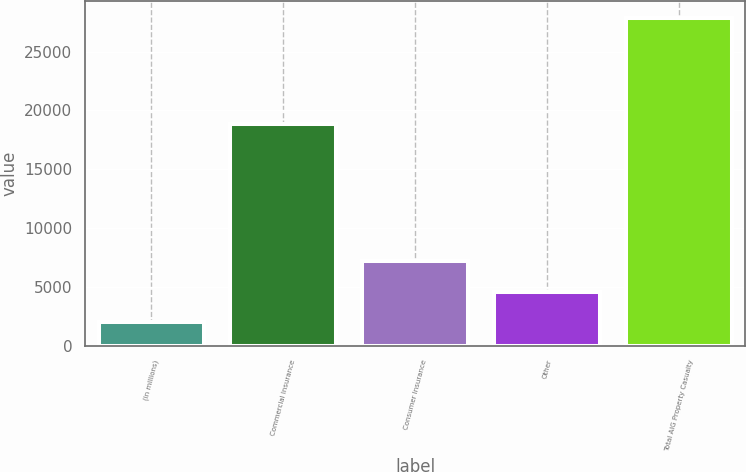Convert chart to OTSL. <chart><loc_0><loc_0><loc_500><loc_500><bar_chart><fcel>(in millions)<fcel>Commercial Insurance<fcel>Consumer Insurance<fcel>Other<fcel>Total AIG Property Casualty<nl><fcel>2010<fcel>18814<fcel>7181.4<fcel>4595.7<fcel>27867<nl></chart> 